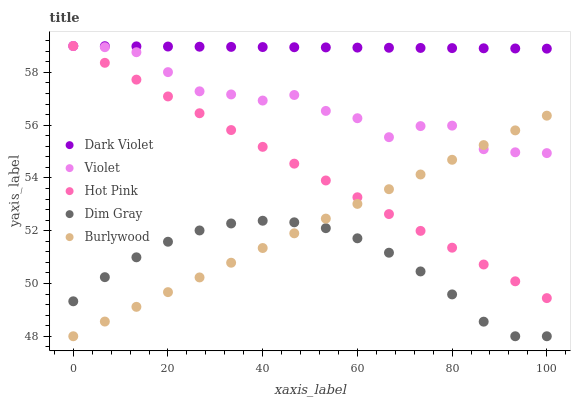Does Dim Gray have the minimum area under the curve?
Answer yes or no. Yes. Does Dark Violet have the maximum area under the curve?
Answer yes or no. Yes. Does Hot Pink have the minimum area under the curve?
Answer yes or no. No. Does Hot Pink have the maximum area under the curve?
Answer yes or no. No. Is Burlywood the smoothest?
Answer yes or no. Yes. Is Violet the roughest?
Answer yes or no. Yes. Is Dim Gray the smoothest?
Answer yes or no. No. Is Dim Gray the roughest?
Answer yes or no. No. Does Burlywood have the lowest value?
Answer yes or no. Yes. Does Hot Pink have the lowest value?
Answer yes or no. No. Does Violet have the highest value?
Answer yes or no. Yes. Does Dim Gray have the highest value?
Answer yes or no. No. Is Burlywood less than Dark Violet?
Answer yes or no. Yes. Is Dark Violet greater than Burlywood?
Answer yes or no. Yes. Does Hot Pink intersect Burlywood?
Answer yes or no. Yes. Is Hot Pink less than Burlywood?
Answer yes or no. No. Is Hot Pink greater than Burlywood?
Answer yes or no. No. Does Burlywood intersect Dark Violet?
Answer yes or no. No. 